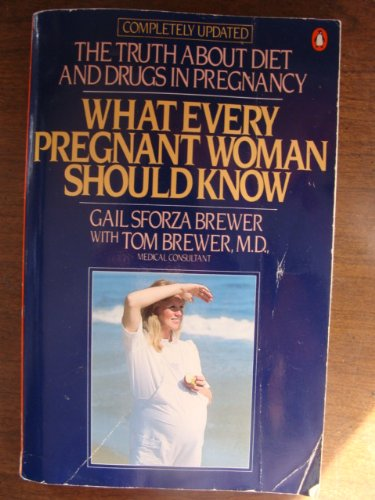Is this a homosexuality book? No, the book specifically concentrates on topics related to pregnancy and does not explore themes of homosexuality. 